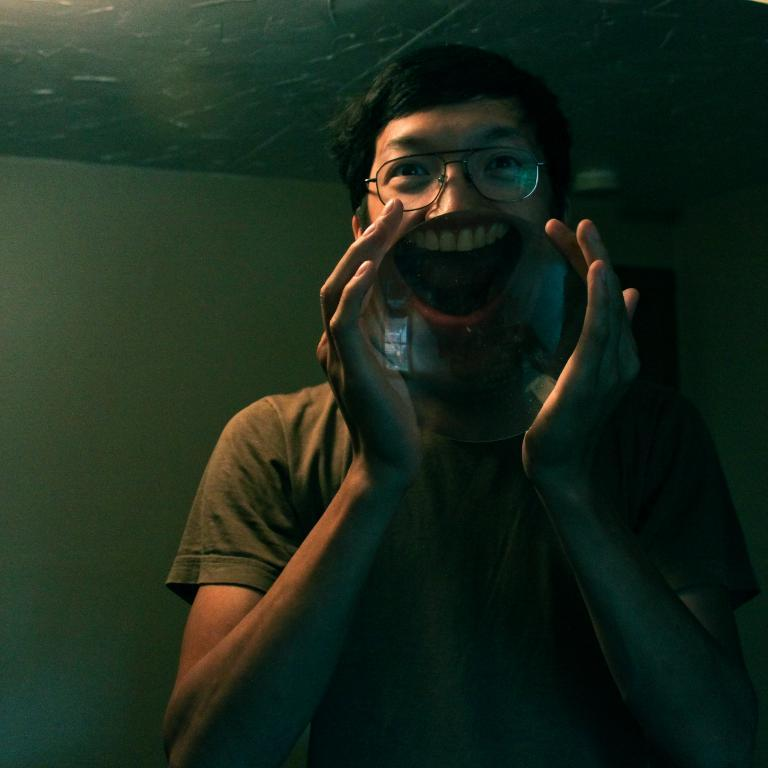What is the person in the image holding? The person is holding a lens in the image. What can be seen in the background of the image? There is a roof, a wall, and a door in the background of the image. What is the view like from the low angle in the image? There is no mention of a low angle in the image, so it's not possible to describe the view from a low angle. 